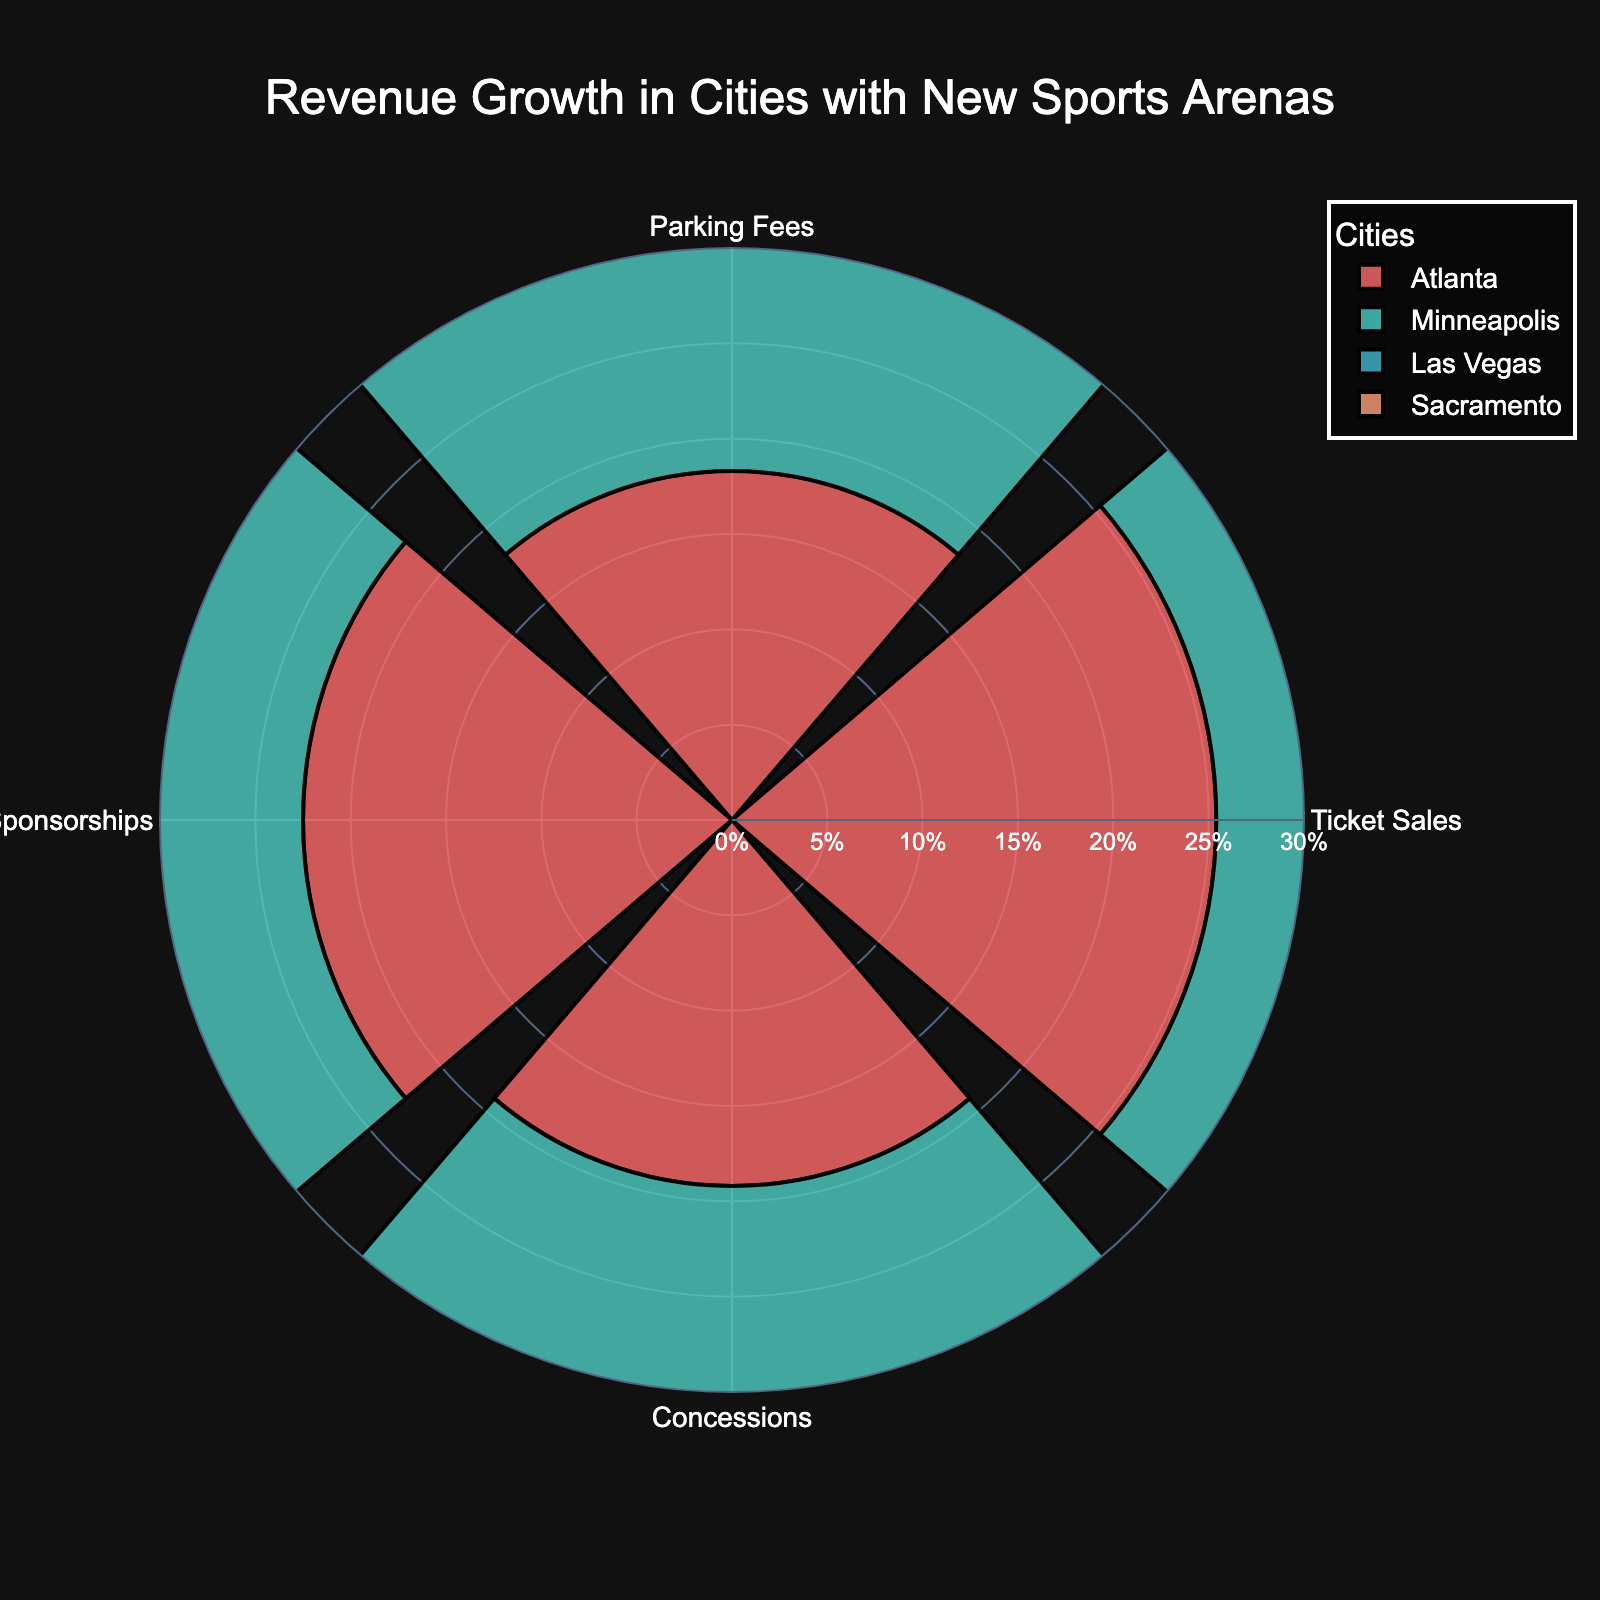How many revenue sources are shown in the figure? The title and radial axes of the figure display different revenue sources, which are visible around the circular plot. Counting them, we see there are four revenue sources.
Answer: Four Which city has the highest revenue growth for ticket sales? To find the highest revenue growth, look at the radial bars labeled "Ticket Sales" for each city. Las Vegas has the highest bar at 27.2%.
Answer: Las Vegas What is the total revenue growth for Minneapolis across all revenue sources? To calculate the total revenue growth for Minneapolis, sum the percentages for Ticket Sales (24.1%), Parking Fees (17.8%), Local Sponsorships (23.3%), and Concessions (20.1%). The total is 24.1 + 17.8 + 23.3 + 20.1 = 85.3%.
Answer: 85.3% Which city shows the most balanced revenue growth across all revenue sources? Analyzing the radial plot, we look for the city whose bars are closest in length. Sacramento has relatively consistent bars across all revenue sources, indicating balanced growth.
Answer: Sacramento Among Parking Fees, which city has the least growth? Comparing the radial bars labeled "Parking Fees" for each city, Minneapolis has the lowest growth at 17.8%.
Answer: Minneapolis What is the difference in growth percentages between Concessions and Local Sponsorships for Atlanta? Concessions for Atlanta show 19.2%, and Local Sponsorships show 22.5%. The difference is 22.5% - 19.2% = 3.3%.
Answer: 3.3% How does the revenue growth in Las Vegas compare to Atlanta in terms of Ticket Sales and Concessions? Las Vegas has a growth of 27.2% in Ticket Sales and 24.7% in Concessions, while Atlanta has 25.4% in Ticket Sales and 19.2% in Concessions. The differences are 27.2% - 25.4% = 1.8% for Ticket Sales and 24.7% - 19.2% = 5.5% for Concessions.
Answer: 1.8% higher for Ticket Sales and 5.5% higher for Concessions Which revenue source shows the highest growth among all cities overall? Analyzing each revenue source across the cities, "Local Sponsorships" in Las Vegas has the highest individual growth bar at 28.4%.
Answer: Local Sponsorships in Las Vegas What are the average growth rates for Ticket Sales across all four cities? Add the Ticket Sales growth rates and divide by the number of cities: (25.4 + 24.1 + 27.2 + 26.1) / 4 = 25.7%.
Answer: 25.7% Between Minneapolis and Sacramento, which city has higher average revenue growth across all sources? Calculate the average for both cities: Minneapolis (24.1 + 17.8 + 23.3 + 20.1) / 4 = 21.325%, Sacramento (26.1 + 19.5 + 24.9 + 21.4) / 4 = 22.975%. Sacramento has the higher average.
Answer: Sacramento 